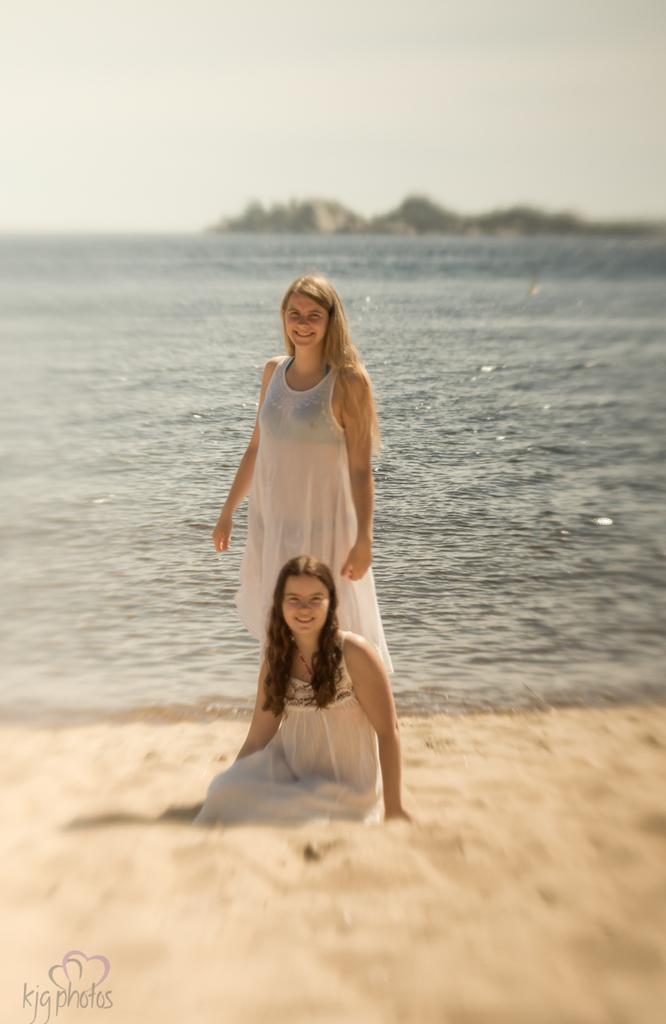Can you describe this image briefly? As we can see in the image there is water, sand and two women wearing white color dresses. At the top there is sky. 